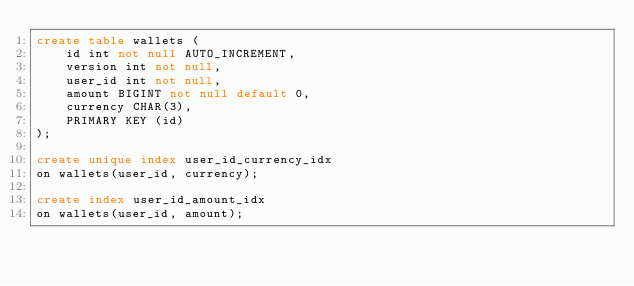Convert code to text. <code><loc_0><loc_0><loc_500><loc_500><_SQL_>create table wallets (
    id int not null AUTO_INCREMENT,
    version int not null,
    user_id int not null,
    amount BIGINT not null default 0,
    currency CHAR(3),
    PRIMARY KEY (id)
);

create unique index user_id_currency_idx
on wallets(user_id, currency);

create index user_id_amount_idx
on wallets(user_id, amount);</code> 